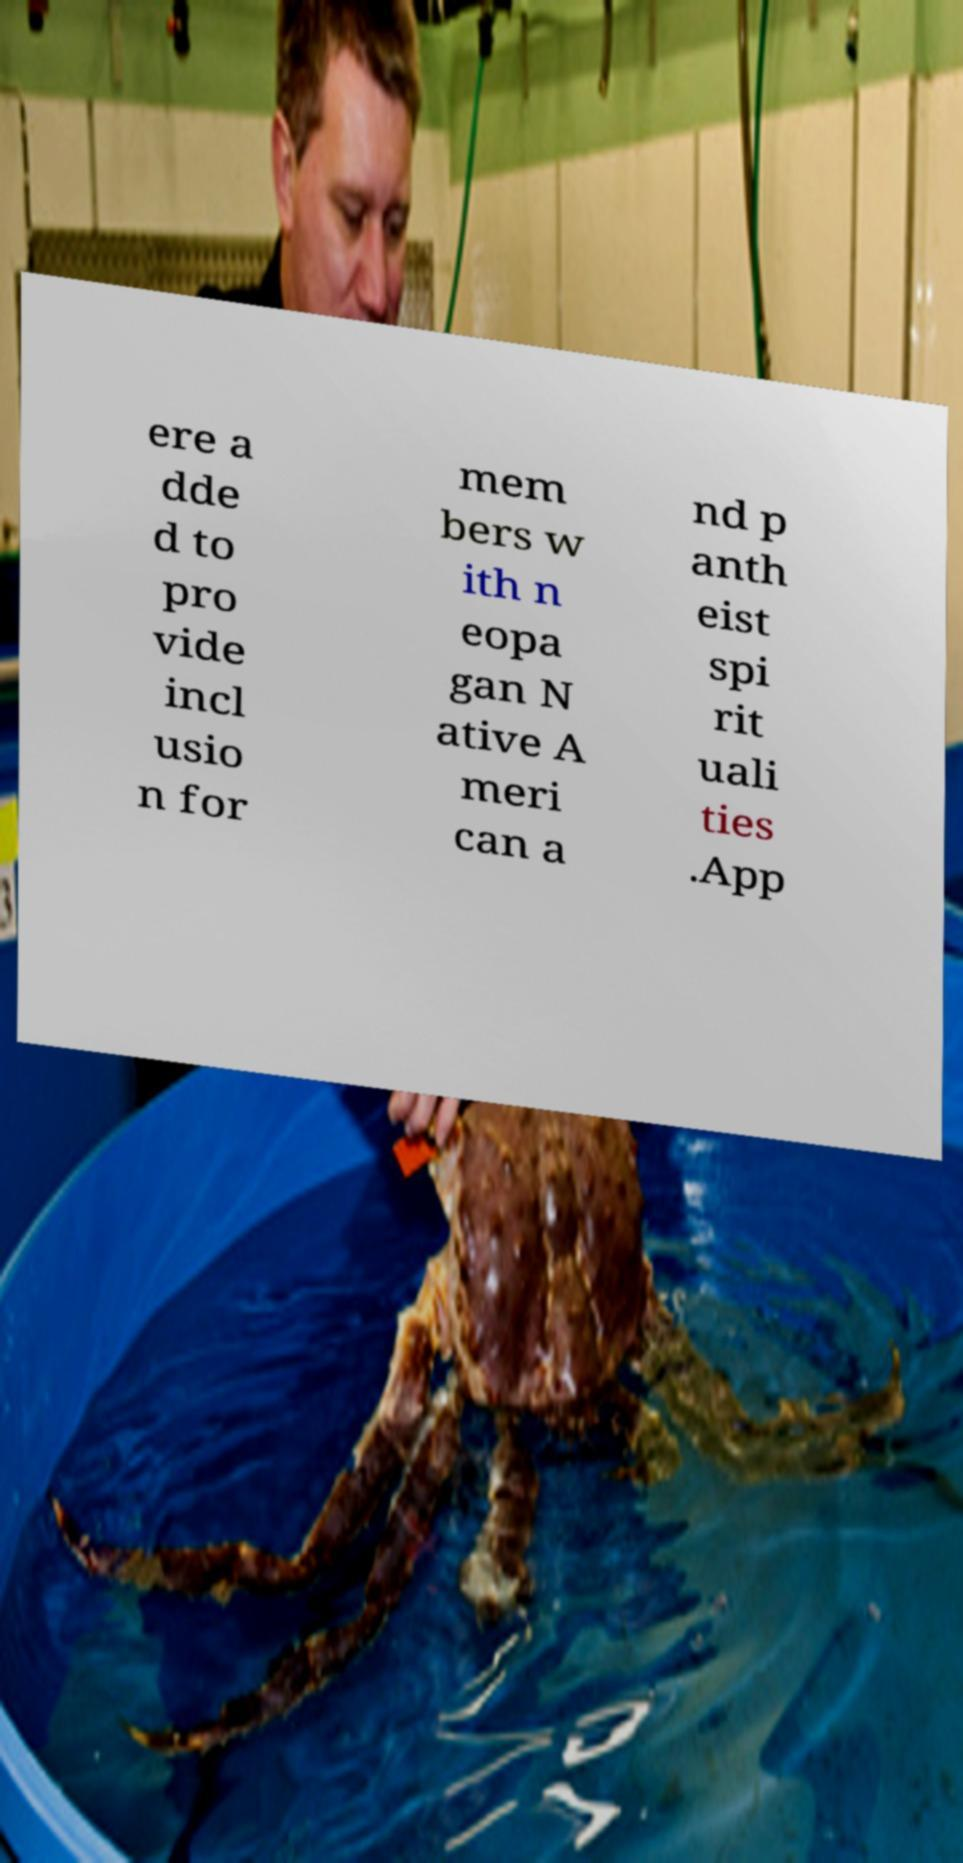Can you accurately transcribe the text from the provided image for me? ere a dde d to pro vide incl usio n for mem bers w ith n eopa gan N ative A meri can a nd p anth eist spi rit uali ties .App 